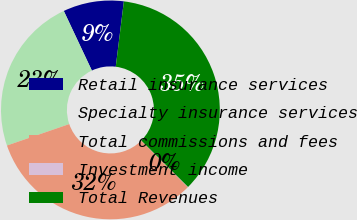<chart> <loc_0><loc_0><loc_500><loc_500><pie_chart><fcel>Retail insurance services<fcel>Specialty insurance services<fcel>Total commissions and fees<fcel>Investment income<fcel>Total Revenues<nl><fcel>8.97%<fcel>23.27%<fcel>32.24%<fcel>0.05%<fcel>35.47%<nl></chart> 